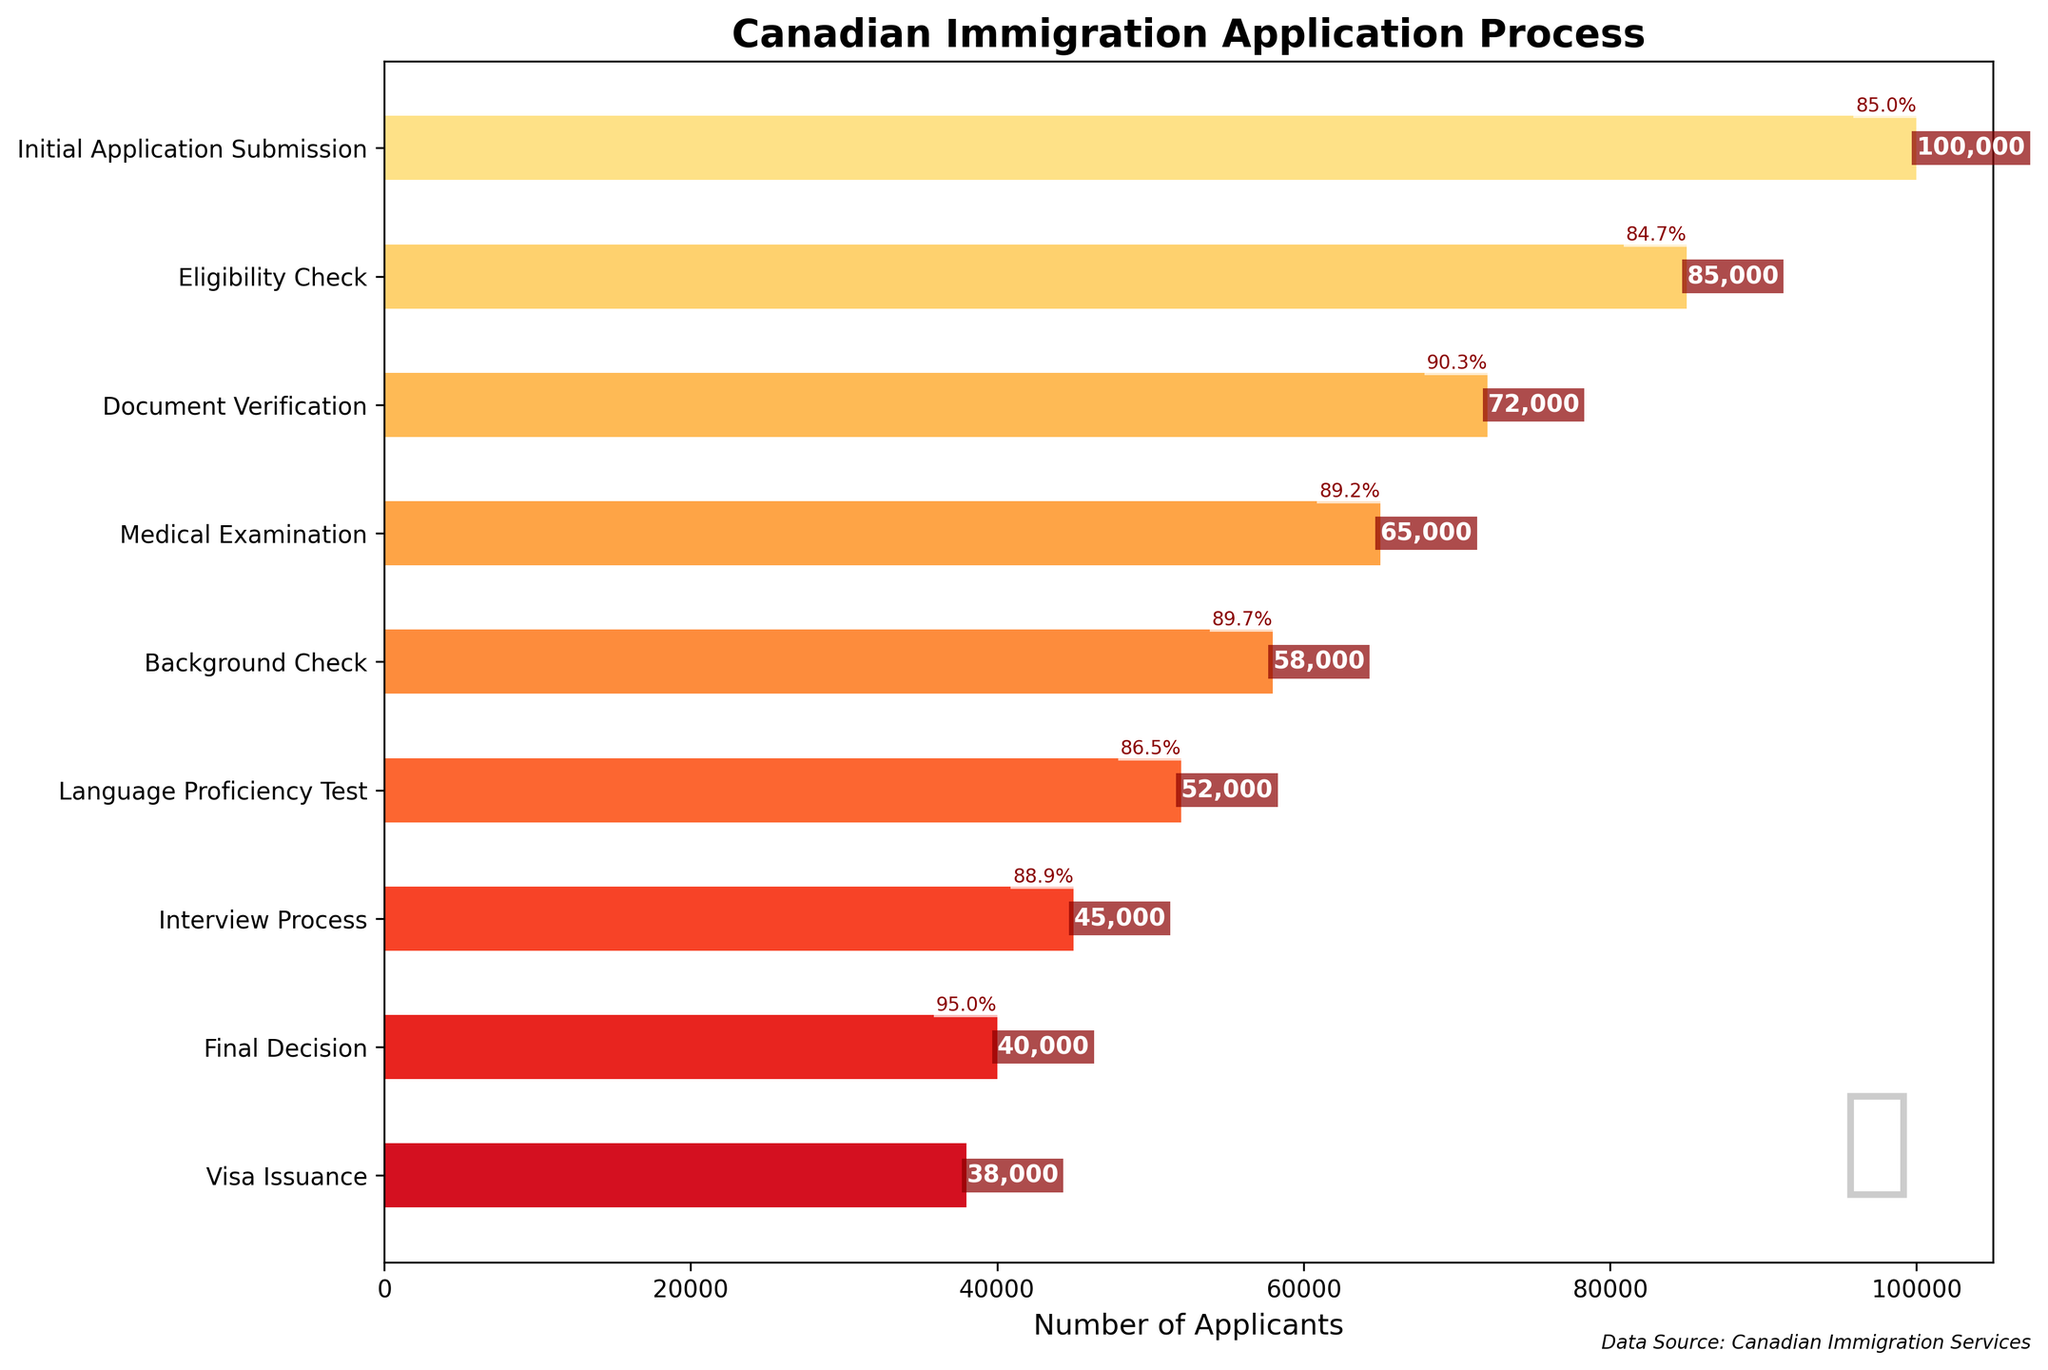How many applicants went through the Eligibility Check stage? Refer to the bar labeled 'Eligibility Check' and its value label. The number of applicants at this stage is displayed directly on the bar.
Answer: 85,000 Which stage has the largest drop in the number of applicants? Compare the differences between the number of applicants in consecutive stages. The largest difference shows the largest drop.
Answer: Eligibility Check What percentage of applicants passed from Medical Examination to Background Check? Calculate the ratio of the number of applicants at the Background Check stage to those at the Medical Examination stage, then convert this ratio to a percentage. (58000 / 65000) * 100 = 89.2%
Answer: 89.2% Across all stages, what is the final approval rate from Initial Application Submission to Visa Issuance? Calculate the ratio of the number of applicants at the Visa Issuance stage to those at the Initial Application Submission stage, then convert this ratio to a percentage. (38000 / 100000) * 100 = 38%
Answer: 38% Compare the number of applicants in the Interview Process stage to those in the Background Check stage. Is it higher, lower, or the same? Directly compare the number labels on the bars labeled 'Background Check' and 'Interview Process'.
Answer: Lower How many stages are there in the Canadian immigration application process shown in the chart? Count the total number of horizontal bars representing each stage in the funnel chart.
Answer: 9 At which stage do the fewest number of applicants remain? Identify the stage with the smallest number label on the horizontal bars.
Answer: Visa Issuance What is the difference in the number of applicants between Document Verification and Final Decision? Subtract the number of applicants at the Final Decision stage from the number in the Document Verification stage. 72,000 - 40,000 = 32,000
Answer: 32,000 How does the number of applicants change from Initial Application Submission to Eligibility Check? Calculate the difference between the 'Initial Application Submission' and 'Eligibility Check' stages, then determine if it is an increase or decrease. 100,000 - 85,000 = 15,000 decrease
Answer: Decrease by 15,000 